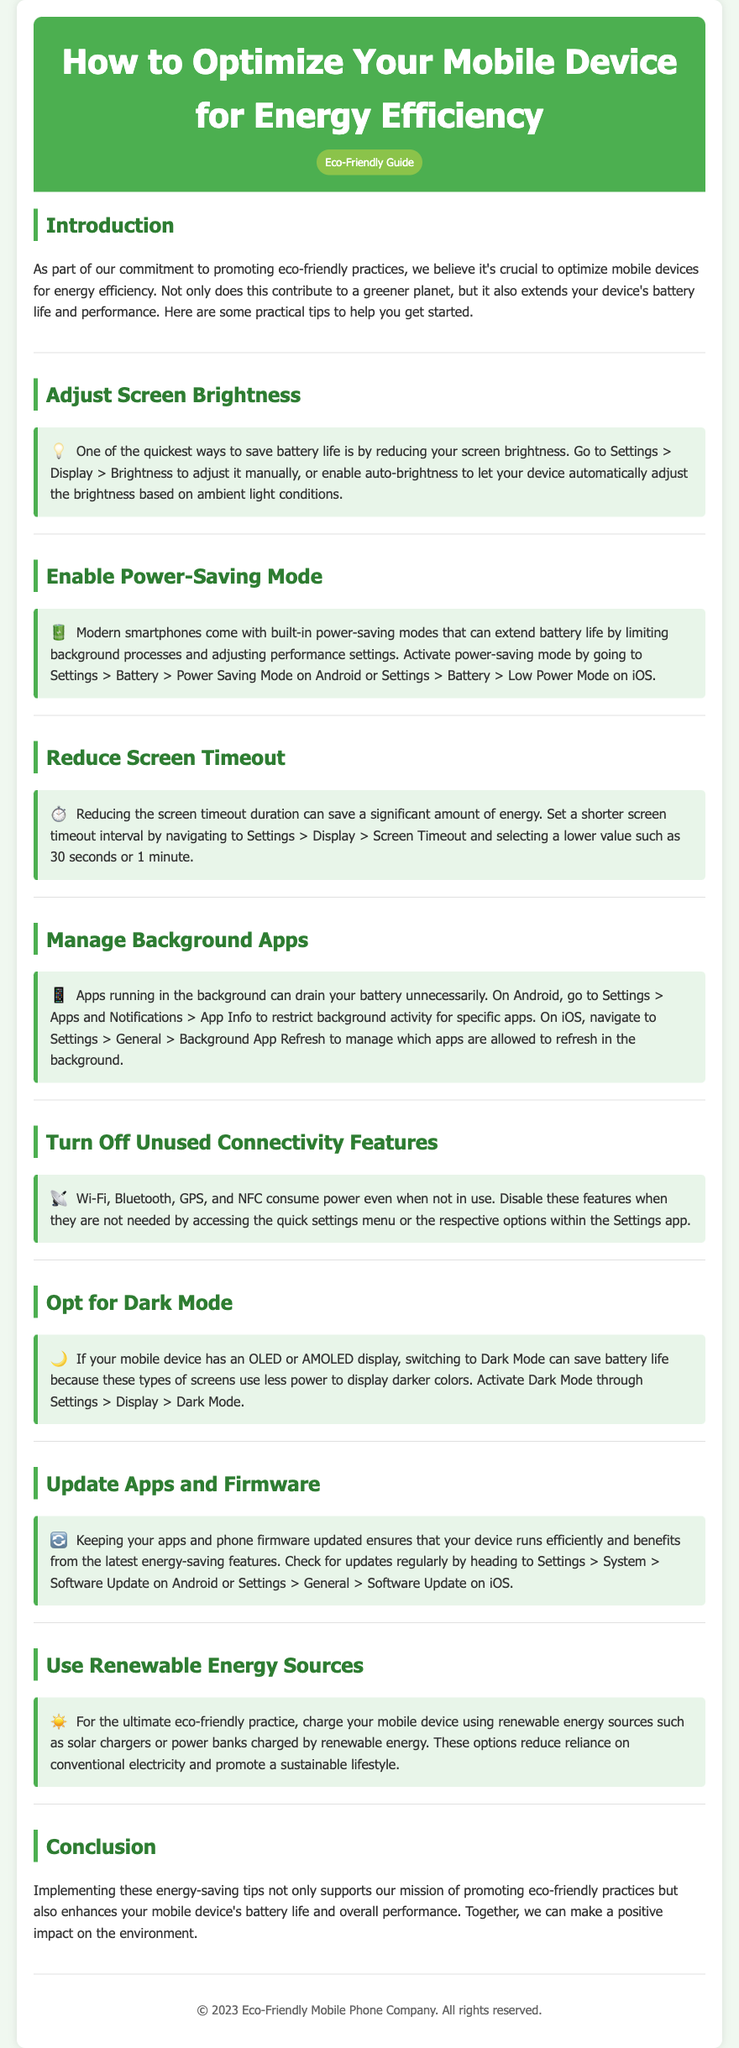what is the title of the document? The title is specified in the head section and indicates the main subject of the document.
Answer: How to Optimize Your Mobile Device for Energy Efficiency how can you enable power-saving mode? The procedure for enabling power-saving mode is outlined in the relevant section.
Answer: Settings > Battery > Power Saving Mode what icon is used for reducing screen timeout? The document provides an icon to visually represent the tip related to screen timeout duration.
Answer: ⏱️ which display mode can save battery life on OLED screens? The guide mentions a specific mode that benefits OLED screens in terms of battery consumption.
Answer: Dark Mode what is one suggested renewable energy source for charging? The guide suggests a specific type of energy source that aligns with the eco-friendly practices promoted in the document.
Answer: Solar chargers how can you manage background apps on iOS? The text explains the steps required to manage apps on this specific operating system.
Answer: Settings > General > Background App Refresh what should you do to keep apps updated? The document outlines the action necessary to ensure apps are regularly updated for efficiency.
Answer: Check for updates regularly which feature should be turned off when not in use? The document identifies specific features that should be disabled to improve battery performance.
Answer: Wi-Fi, Bluetooth, GPS, and NFC why is reducing screen brightness recommended? The document provides a rationale behind reducing screen brightness related to battery usage.
Answer: Saves battery life 